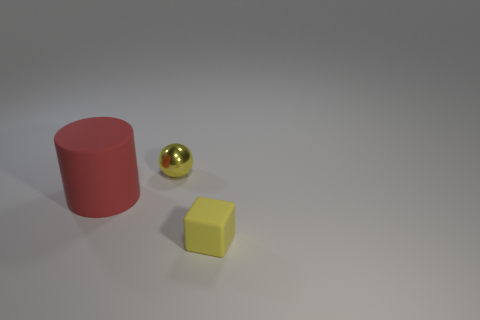Add 1 small yellow things. How many objects exist? 4 Subtract all blocks. How many objects are left? 2 Subtract all red spheres. Subtract all yellow objects. How many objects are left? 1 Add 3 small things. How many small things are left? 5 Add 3 big cyan shiny balls. How many big cyan shiny balls exist? 3 Subtract 1 yellow spheres. How many objects are left? 2 